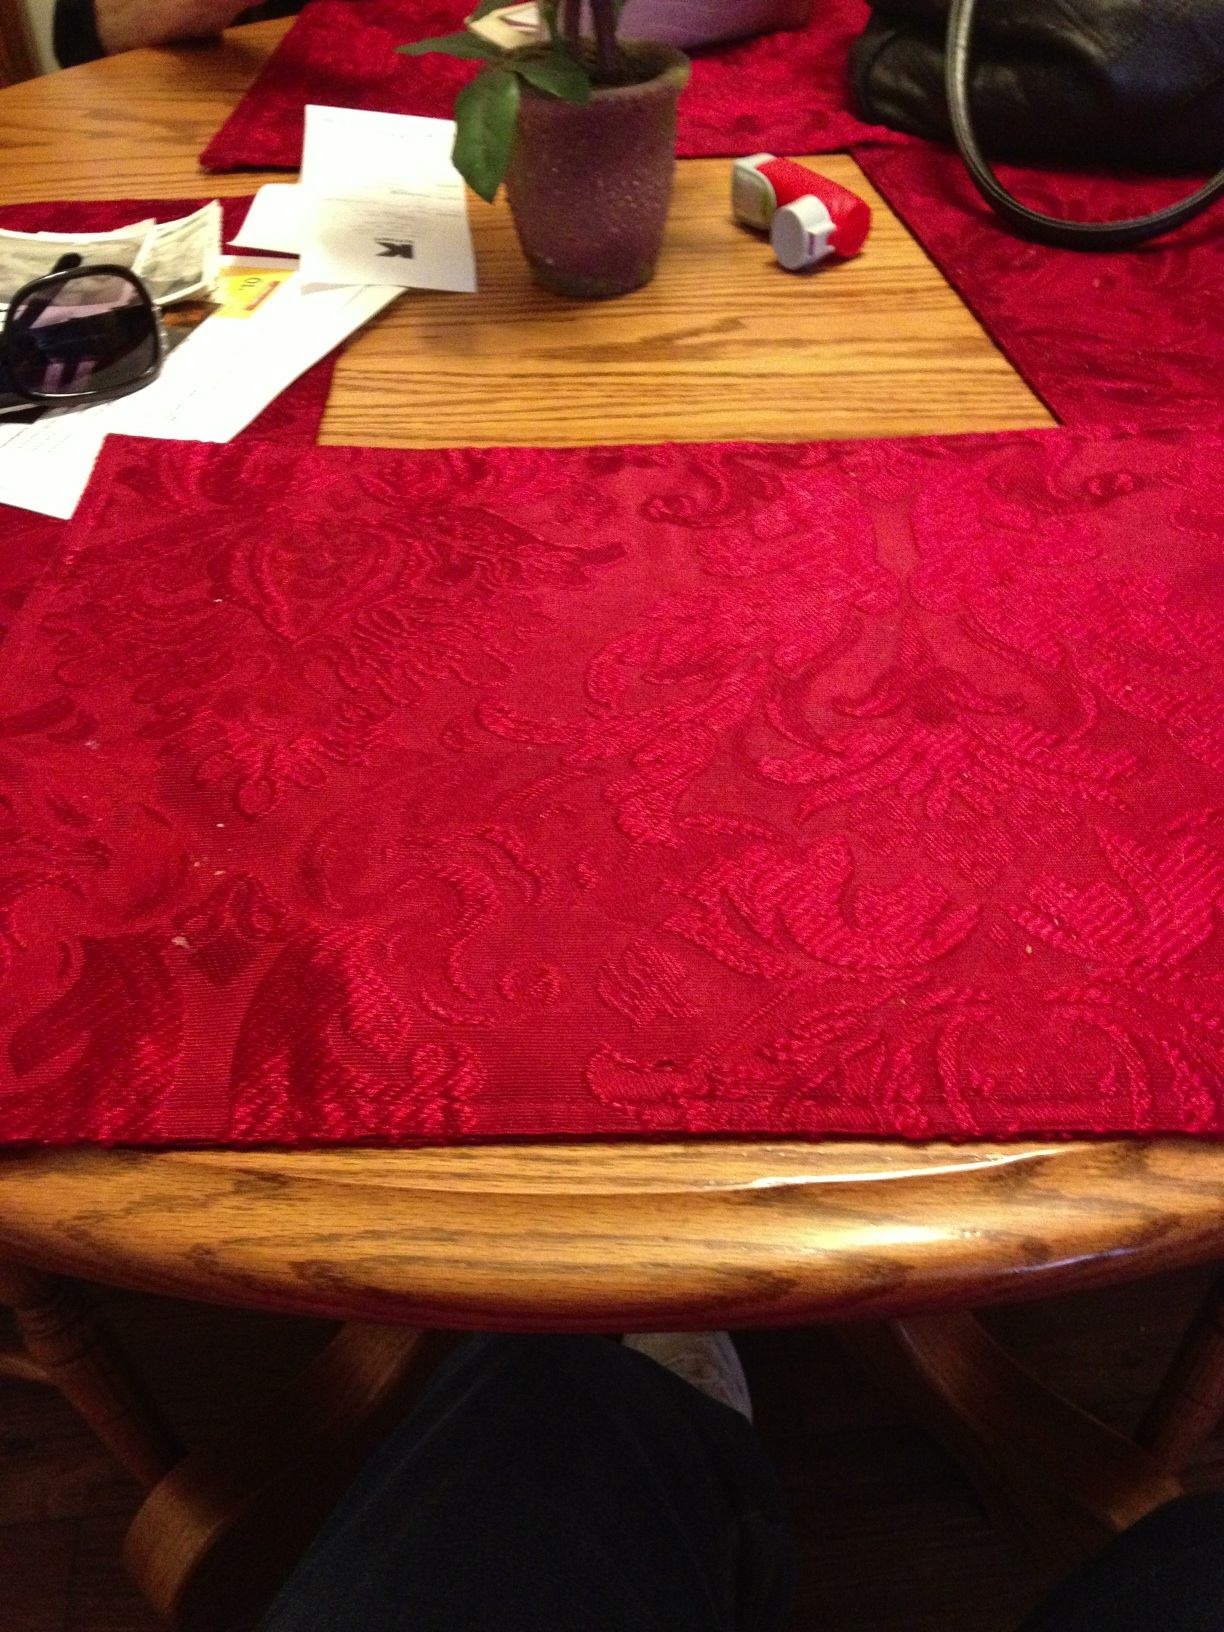Can you describe the other items seen on the table? Certainly! Alongside the burgundy mat, there's a variety of items on the wooden table. There's a purple pot containing a green plant, possibly a houseplant given for ambiance. Scattered about are personal items: a pair of sunglasses, some papers which may be mail or notes, and a black purse suggesting the presence of someone who perhaps just arrived or is ready to leave. A wooden board under the pot suggests an effort to protect the table surface from water damage. 